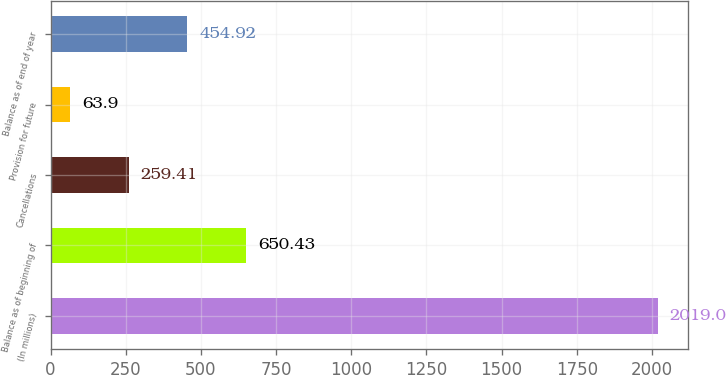<chart> <loc_0><loc_0><loc_500><loc_500><bar_chart><fcel>(In millions)<fcel>Balance as of beginning of<fcel>Cancellations<fcel>Provision for future<fcel>Balance as of end of year<nl><fcel>2019<fcel>650.43<fcel>259.41<fcel>63.9<fcel>454.92<nl></chart> 